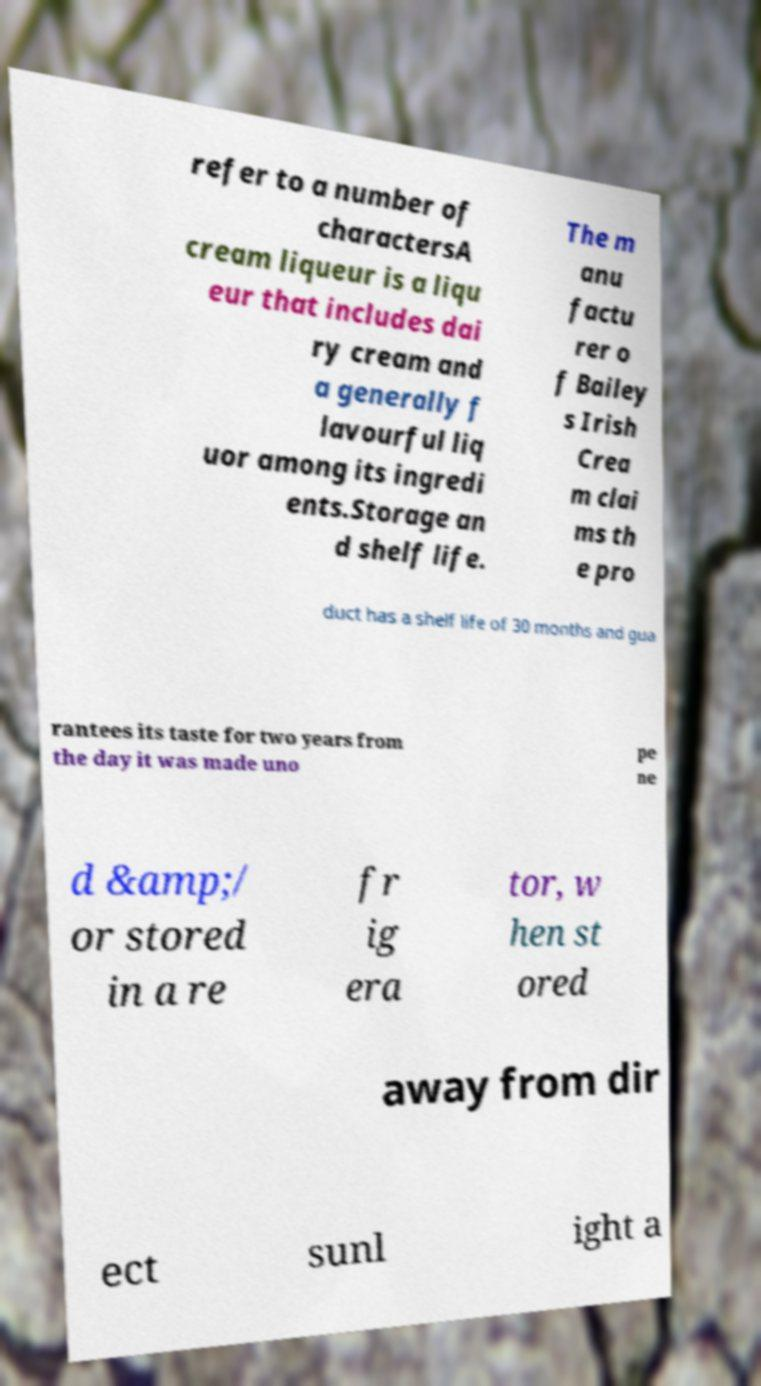Can you read and provide the text displayed in the image?This photo seems to have some interesting text. Can you extract and type it out for me? refer to a number of charactersA cream liqueur is a liqu eur that includes dai ry cream and a generally f lavourful liq uor among its ingredi ents.Storage an d shelf life. The m anu factu rer o f Bailey s Irish Crea m clai ms th e pro duct has a shelf life of 30 months and gua rantees its taste for two years from the day it was made uno pe ne d &amp;/ or stored in a re fr ig era tor, w hen st ored away from dir ect sunl ight a 